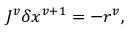Convert formula to latex. <formula><loc_0><loc_0><loc_500><loc_500>J ^ { v } \delta x ^ { v + 1 } = - r ^ { v } ,</formula> 